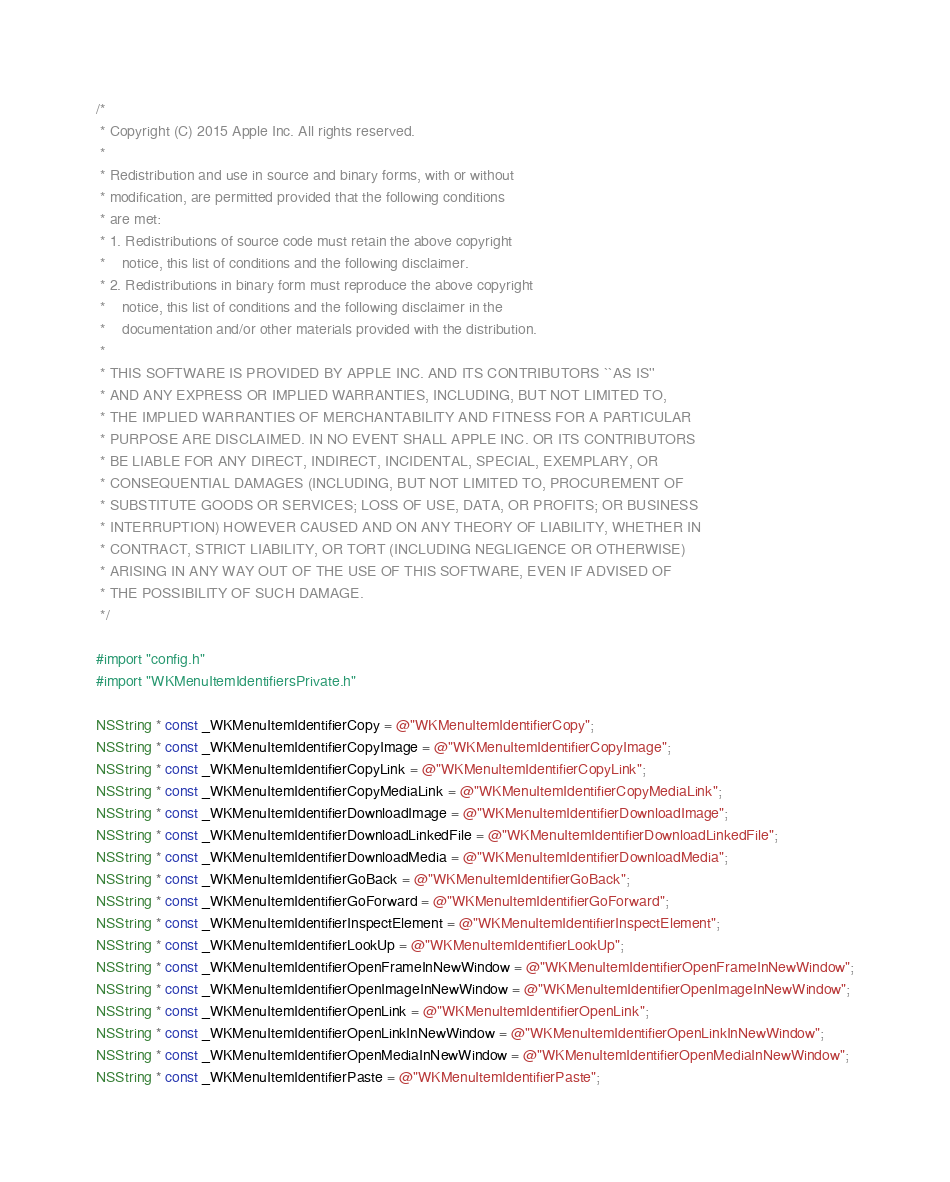<code> <loc_0><loc_0><loc_500><loc_500><_ObjectiveC_>/*
 * Copyright (C) 2015 Apple Inc. All rights reserved.
 *
 * Redistribution and use in source and binary forms, with or without
 * modification, are permitted provided that the following conditions
 * are met:
 * 1. Redistributions of source code must retain the above copyright
 *    notice, this list of conditions and the following disclaimer.
 * 2. Redistributions in binary form must reproduce the above copyright
 *    notice, this list of conditions and the following disclaimer in the
 *    documentation and/or other materials provided with the distribution.
 *
 * THIS SOFTWARE IS PROVIDED BY APPLE INC. AND ITS CONTRIBUTORS ``AS IS''
 * AND ANY EXPRESS OR IMPLIED WARRANTIES, INCLUDING, BUT NOT LIMITED TO,
 * THE IMPLIED WARRANTIES OF MERCHANTABILITY AND FITNESS FOR A PARTICULAR
 * PURPOSE ARE DISCLAIMED. IN NO EVENT SHALL APPLE INC. OR ITS CONTRIBUTORS
 * BE LIABLE FOR ANY DIRECT, INDIRECT, INCIDENTAL, SPECIAL, EXEMPLARY, OR
 * CONSEQUENTIAL DAMAGES (INCLUDING, BUT NOT LIMITED TO, PROCUREMENT OF
 * SUBSTITUTE GOODS OR SERVICES; LOSS OF USE, DATA, OR PROFITS; OR BUSINESS
 * INTERRUPTION) HOWEVER CAUSED AND ON ANY THEORY OF LIABILITY, WHETHER IN
 * CONTRACT, STRICT LIABILITY, OR TORT (INCLUDING NEGLIGENCE OR OTHERWISE)
 * ARISING IN ANY WAY OUT OF THE USE OF THIS SOFTWARE, EVEN IF ADVISED OF
 * THE POSSIBILITY OF SUCH DAMAGE.
 */

#import "config.h"
#import "WKMenuItemIdentifiersPrivate.h"

NSString * const _WKMenuItemIdentifierCopy = @"WKMenuItemIdentifierCopy";
NSString * const _WKMenuItemIdentifierCopyImage = @"WKMenuItemIdentifierCopyImage";
NSString * const _WKMenuItemIdentifierCopyLink = @"WKMenuItemIdentifierCopyLink";
NSString * const _WKMenuItemIdentifierCopyMediaLink = @"WKMenuItemIdentifierCopyMediaLink";
NSString * const _WKMenuItemIdentifierDownloadImage = @"WKMenuItemIdentifierDownloadImage";
NSString * const _WKMenuItemIdentifierDownloadLinkedFile = @"WKMenuItemIdentifierDownloadLinkedFile";
NSString * const _WKMenuItemIdentifierDownloadMedia = @"WKMenuItemIdentifierDownloadMedia";
NSString * const _WKMenuItemIdentifierGoBack = @"WKMenuItemIdentifierGoBack";
NSString * const _WKMenuItemIdentifierGoForward = @"WKMenuItemIdentifierGoForward";
NSString * const _WKMenuItemIdentifierInspectElement = @"WKMenuItemIdentifierInspectElement";
NSString * const _WKMenuItemIdentifierLookUp = @"WKMenuItemIdentifierLookUp";
NSString * const _WKMenuItemIdentifierOpenFrameInNewWindow = @"WKMenuItemIdentifierOpenFrameInNewWindow";
NSString * const _WKMenuItemIdentifierOpenImageInNewWindow = @"WKMenuItemIdentifierOpenImageInNewWindow";
NSString * const _WKMenuItemIdentifierOpenLink = @"WKMenuItemIdentifierOpenLink";
NSString * const _WKMenuItemIdentifierOpenLinkInNewWindow = @"WKMenuItemIdentifierOpenLinkInNewWindow";
NSString * const _WKMenuItemIdentifierOpenMediaInNewWindow = @"WKMenuItemIdentifierOpenMediaInNewWindow";
NSString * const _WKMenuItemIdentifierPaste = @"WKMenuItemIdentifierPaste";</code> 